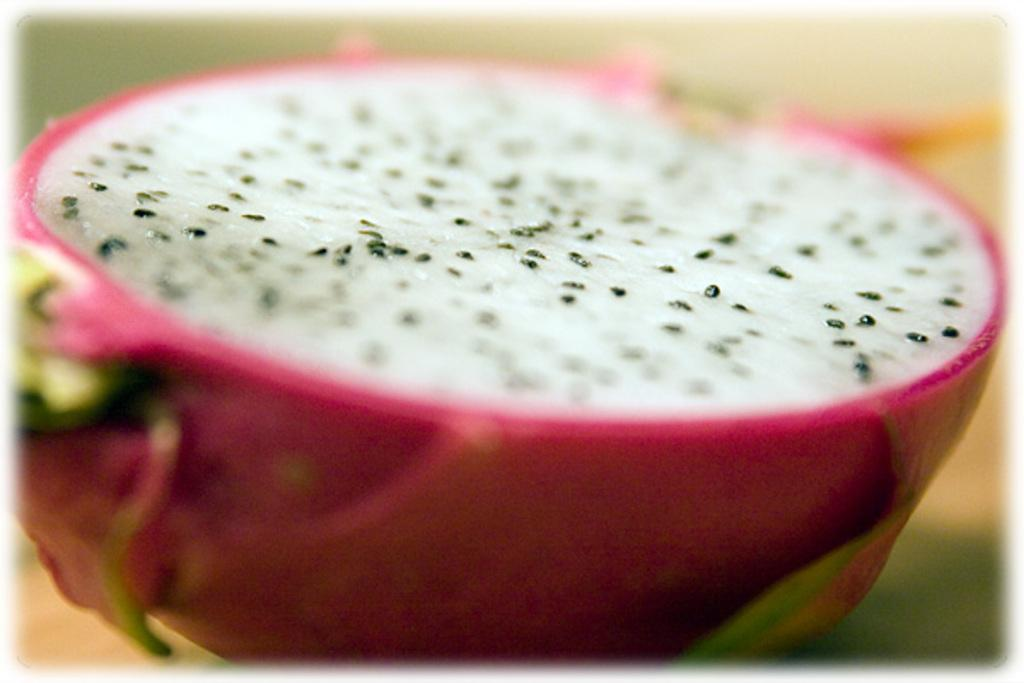What type of picture is the image? The image is a zoomed in picture. What is the main subject of the image? The subject of the image is a dragon fruit. What type of metal can be seen in the image? There is no metal present in the image; it features a dragon fruit. How many pigs are visible in the image? There are no pigs present in the image; it features a dragon fruit. 